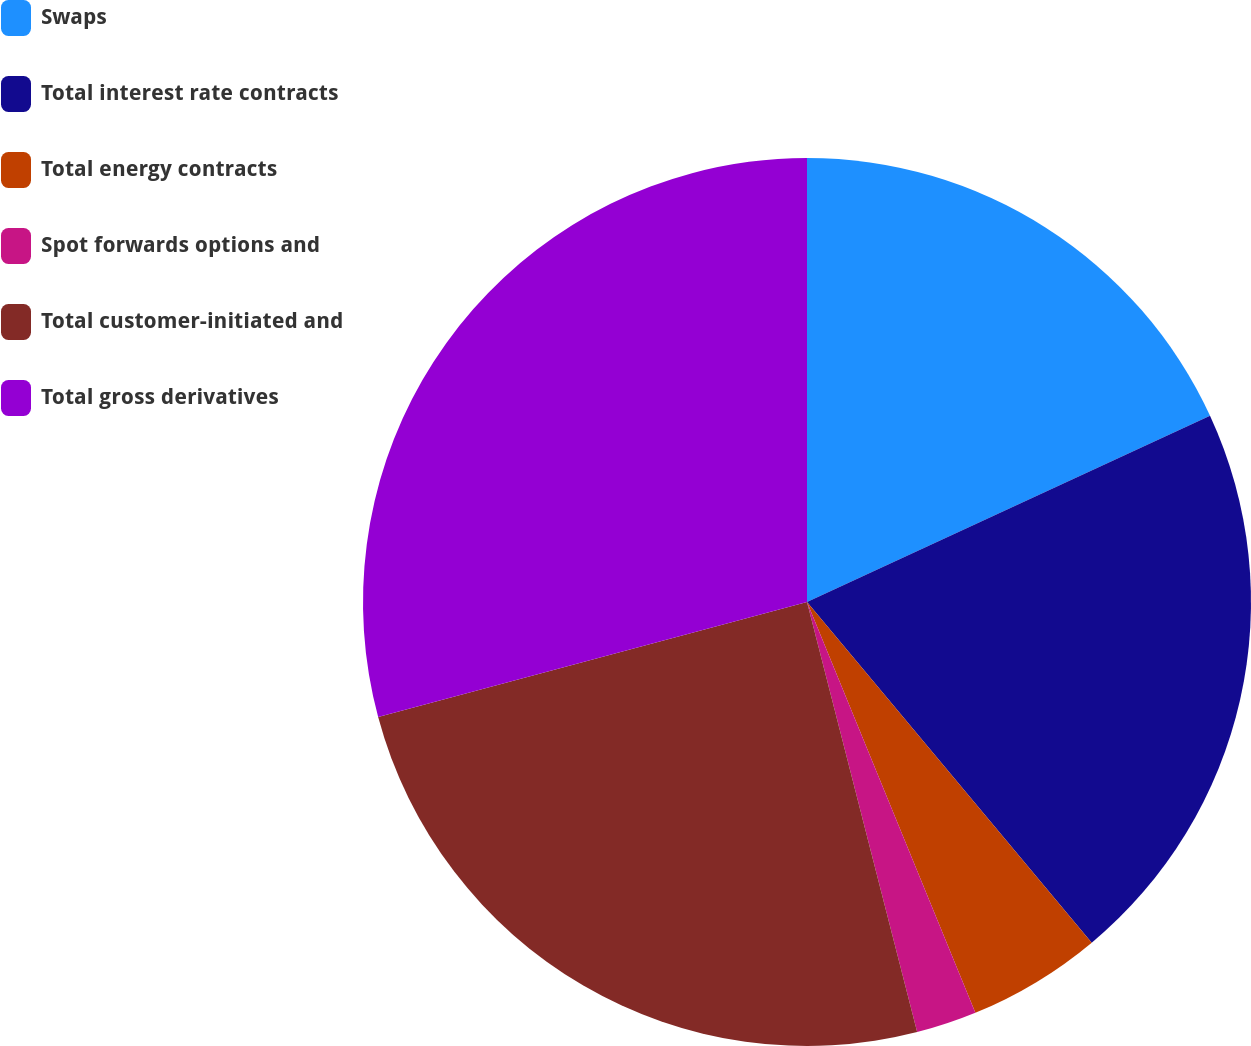<chart> <loc_0><loc_0><loc_500><loc_500><pie_chart><fcel>Swaps<fcel>Total interest rate contracts<fcel>Total energy contracts<fcel>Spot forwards options and<fcel>Total customer-initiated and<fcel>Total gross derivatives<nl><fcel>18.11%<fcel>20.81%<fcel>4.89%<fcel>2.2%<fcel>24.82%<fcel>29.17%<nl></chart> 